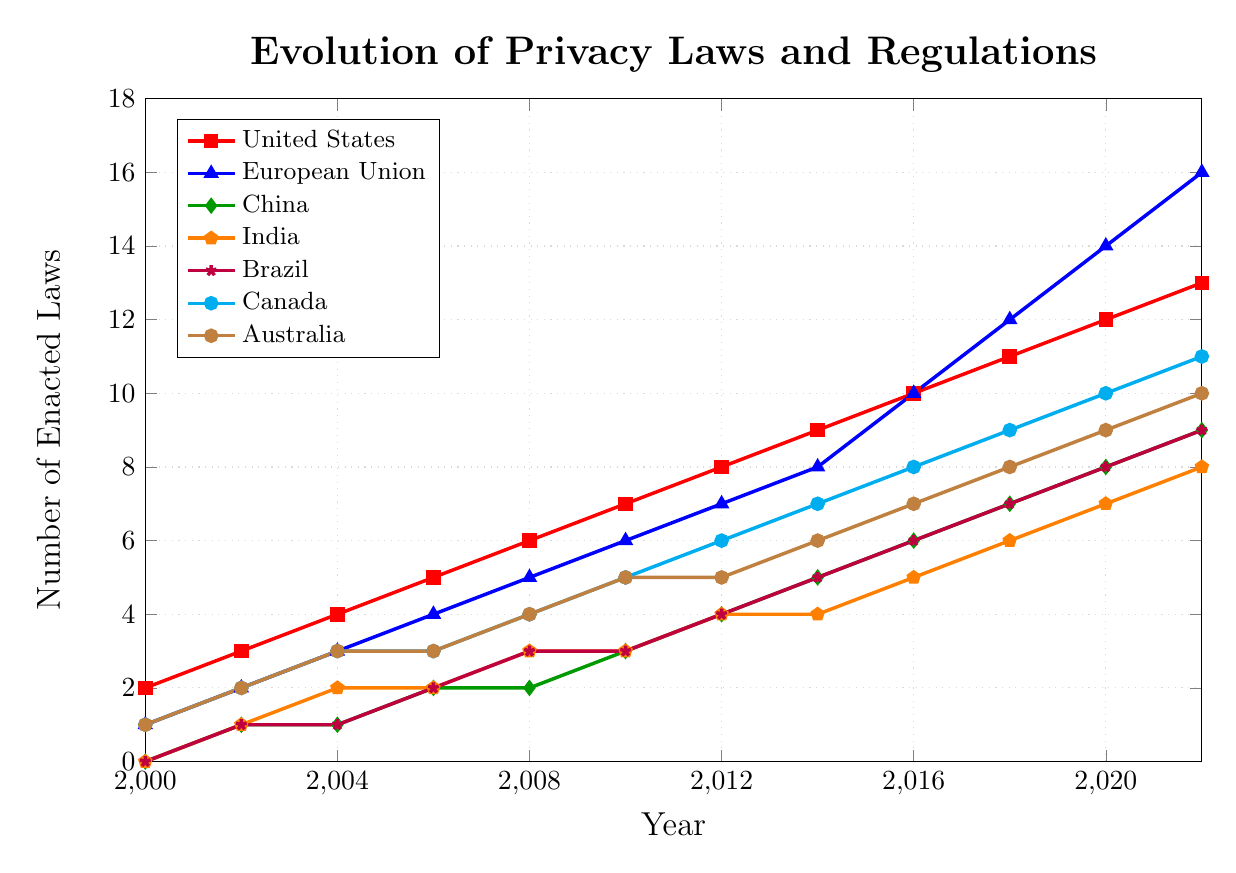what year does the European Union reach double digits in the number of enacted privacy laws? By visually scanning the plot, we notice that the European Union reaches 10 enacted privacy laws around the year 2016.
Answer: 2016 Which country had the largest increase in the number of privacy laws between 2018 and 2020? By comparing the slopes of the lines between 2018 and 2020, the European Union increased from 12 to 14, which is the largest increment of 2 laws.
Answer: European Union How many more privacy laws were enacted by the United States compared to Brazil by 2022? The United States had 13 laws in 2022, while Brazil had 9. The difference is calculated as 13 - 9.
Answer: 4 In what year did India first surpass 3 enacted privacy laws? By locating the data points for India, we can see that India surpassed 3 laws between 2010 and 2012 as it continued to rise.
Answer: 2012 What is the trend in privacy laws enacted by Australia from 2000 to 2022? The line corresponding to Australia shows a consistent upward trend, starting at 1 law in 2000 and increasing to 10 laws by 2022.
Answer: Upward trend Which two countries have equal numbers of enacted privacy laws in any year, and in what year? Upon inspection, in 2014 both India and China had 4 privacy laws enacted.
Answer: India and China, 2014 Calculate the average number of privacy laws enacted by Canada from 2000 to 2022? Sum the values for Canada (1, 2, 3, 3, 4, 5, 6, 7, 8, 9, 10, 11) and divide by the number of data points (12). The sum is 69, and the average is 69/12.
Answer: 5.75 What is the difference in the number of privacy laws between China and India in 2012? In 2012, China had 4 enacted privacy laws, and India also had 4, so the difference is 4 - 4.
Answer: 0 